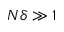<formula> <loc_0><loc_0><loc_500><loc_500>N \delta \gg 1</formula> 